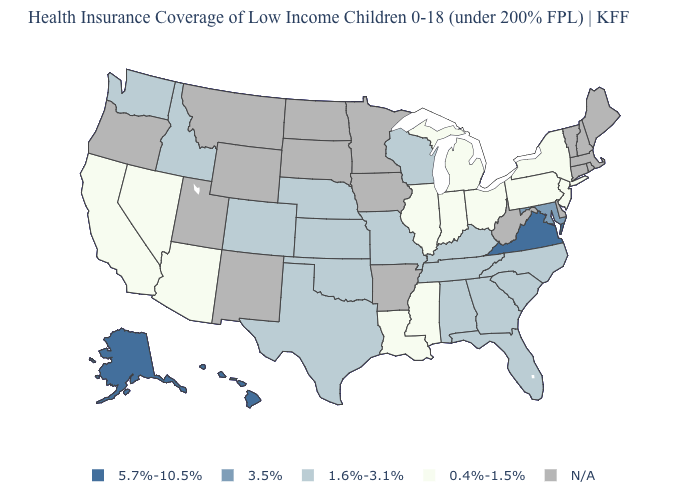What is the lowest value in the USA?
Short answer required. 0.4%-1.5%. What is the highest value in the USA?
Quick response, please. 5.7%-10.5%. What is the value of South Carolina?
Concise answer only. 1.6%-3.1%. How many symbols are there in the legend?
Be succinct. 5. What is the lowest value in states that border North Carolina?
Keep it brief. 1.6%-3.1%. What is the value of Pennsylvania?
Keep it brief. 0.4%-1.5%. Which states have the highest value in the USA?
Keep it brief. Alaska, Hawaii, Virginia. Name the states that have a value in the range 3.5%?
Answer briefly. Maryland. How many symbols are there in the legend?
Keep it brief. 5. Does Nebraska have the highest value in the MidWest?
Write a very short answer. Yes. Among the states that border Wisconsin , which have the highest value?
Be succinct. Illinois, Michigan. Name the states that have a value in the range 3.5%?
Quick response, please. Maryland. What is the lowest value in the South?
Give a very brief answer. 0.4%-1.5%. What is the value of Pennsylvania?
Answer briefly. 0.4%-1.5%. 